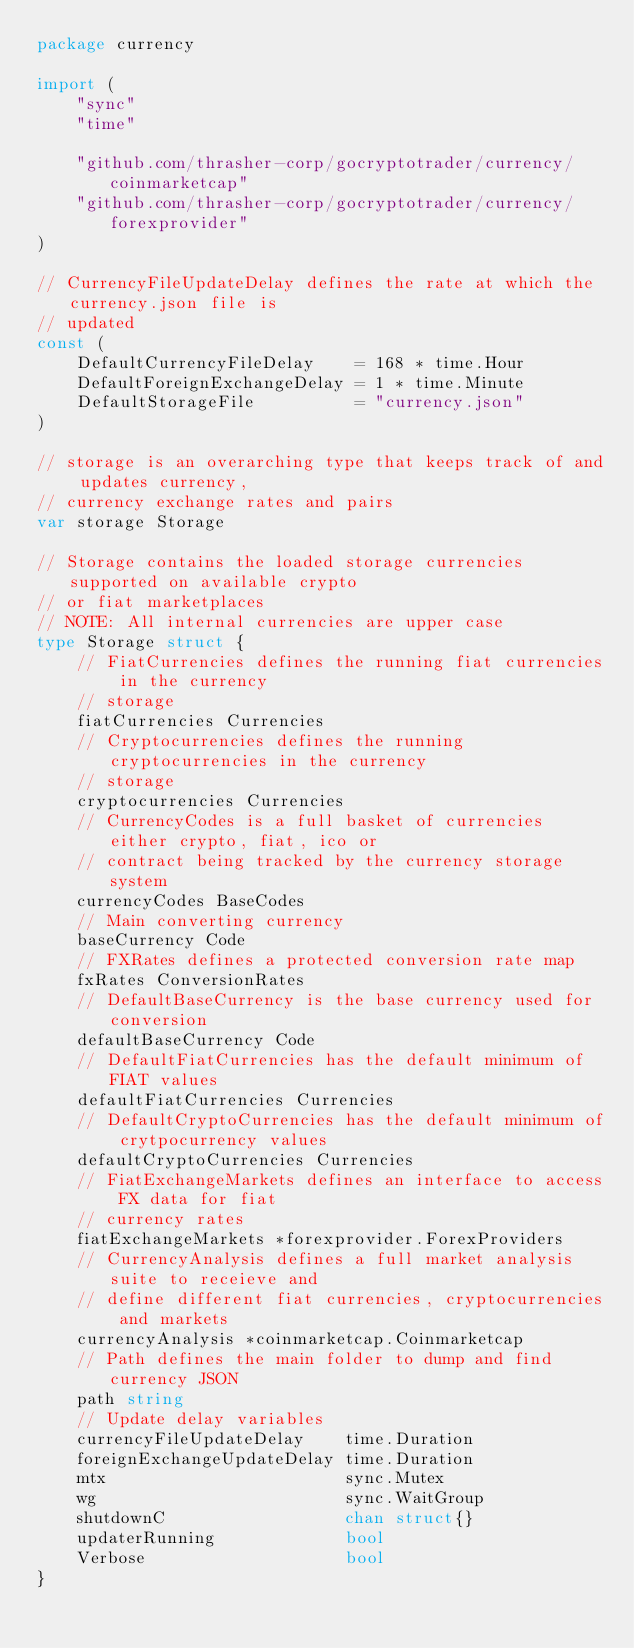Convert code to text. <code><loc_0><loc_0><loc_500><loc_500><_Go_>package currency

import (
	"sync"
	"time"

	"github.com/thrasher-corp/gocryptotrader/currency/coinmarketcap"
	"github.com/thrasher-corp/gocryptotrader/currency/forexprovider"
)

// CurrencyFileUpdateDelay defines the rate at which the currency.json file is
// updated
const (
	DefaultCurrencyFileDelay    = 168 * time.Hour
	DefaultForeignExchangeDelay = 1 * time.Minute
	DefaultStorageFile          = "currency.json"
)

// storage is an overarching type that keeps track of and updates currency,
// currency exchange rates and pairs
var storage Storage

// Storage contains the loaded storage currencies supported on available crypto
// or fiat marketplaces
// NOTE: All internal currencies are upper case
type Storage struct {
	// FiatCurrencies defines the running fiat currencies in the currency
	// storage
	fiatCurrencies Currencies
	// Cryptocurrencies defines the running cryptocurrencies in the currency
	// storage
	cryptocurrencies Currencies
	// CurrencyCodes is a full basket of currencies either crypto, fiat, ico or
	// contract being tracked by the currency storage system
	currencyCodes BaseCodes
	// Main converting currency
	baseCurrency Code
	// FXRates defines a protected conversion rate map
	fxRates ConversionRates
	// DefaultBaseCurrency is the base currency used for conversion
	defaultBaseCurrency Code
	// DefaultFiatCurrencies has the default minimum of FIAT values
	defaultFiatCurrencies Currencies
	// DefaultCryptoCurrencies has the default minimum of crytpocurrency values
	defaultCryptoCurrencies Currencies
	// FiatExchangeMarkets defines an interface to access FX data for fiat
	// currency rates
	fiatExchangeMarkets *forexprovider.ForexProviders
	// CurrencyAnalysis defines a full market analysis suite to receieve and
	// define different fiat currencies, cryptocurrencies and markets
	currencyAnalysis *coinmarketcap.Coinmarketcap
	// Path defines the main folder to dump and find currency JSON
	path string
	// Update delay variables
	currencyFileUpdateDelay    time.Duration
	foreignExchangeUpdateDelay time.Duration
	mtx                        sync.Mutex
	wg                         sync.WaitGroup
	shutdownC                  chan struct{}
	updaterRunning             bool
	Verbose                    bool
}
</code> 